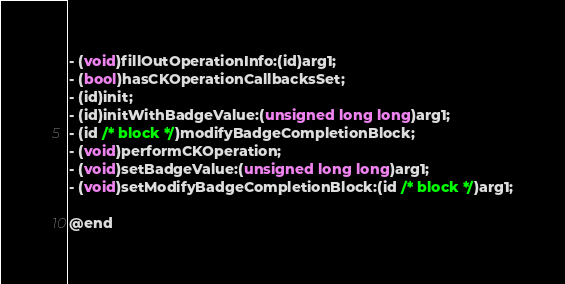Convert code to text. <code><loc_0><loc_0><loc_500><loc_500><_C_>- (void)fillOutOperationInfo:(id)arg1;
- (bool)hasCKOperationCallbacksSet;
- (id)init;
- (id)initWithBadgeValue:(unsigned long long)arg1;
- (id /* block */)modifyBadgeCompletionBlock;
- (void)performCKOperation;
- (void)setBadgeValue:(unsigned long long)arg1;
- (void)setModifyBadgeCompletionBlock:(id /* block */)arg1;

@end
</code> 